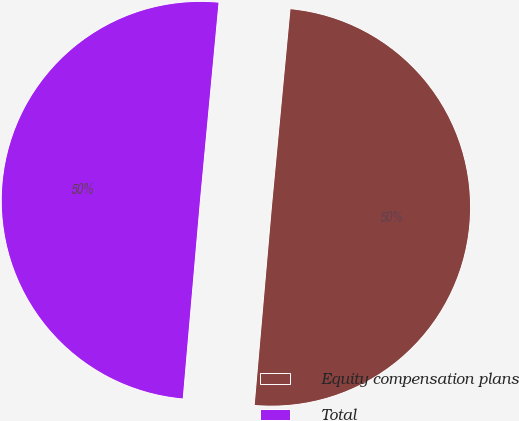Convert chart. <chart><loc_0><loc_0><loc_500><loc_500><pie_chart><fcel>Equity compensation plans<fcel>Total<nl><fcel>49.89%<fcel>50.11%<nl></chart> 